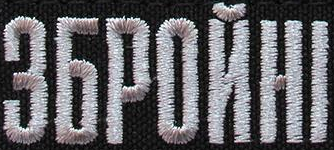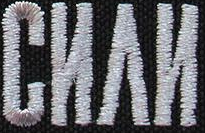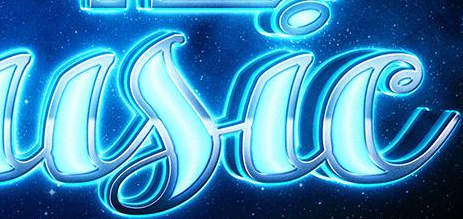What text is displayed in these images sequentially, separated by a semicolon? ЗБPOЙHI; CИΛИ; usic 